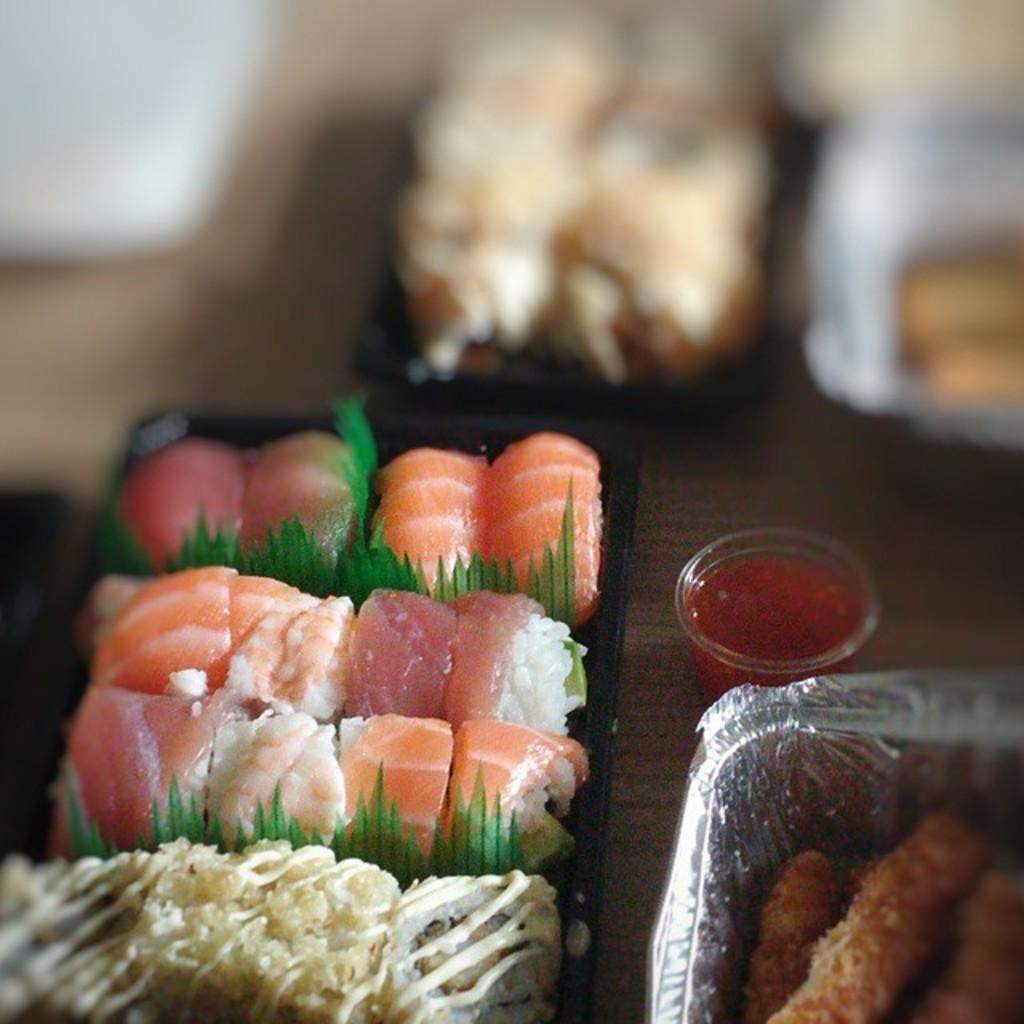How would you summarize this image in a sentence or two? On a platform we can see on the left side there is meat and a food item in a plate and in the background the image is blur but we can see food items in the plates and on the right at the bottom corner we can see food item in a silver plate and sauce in a small cup. 